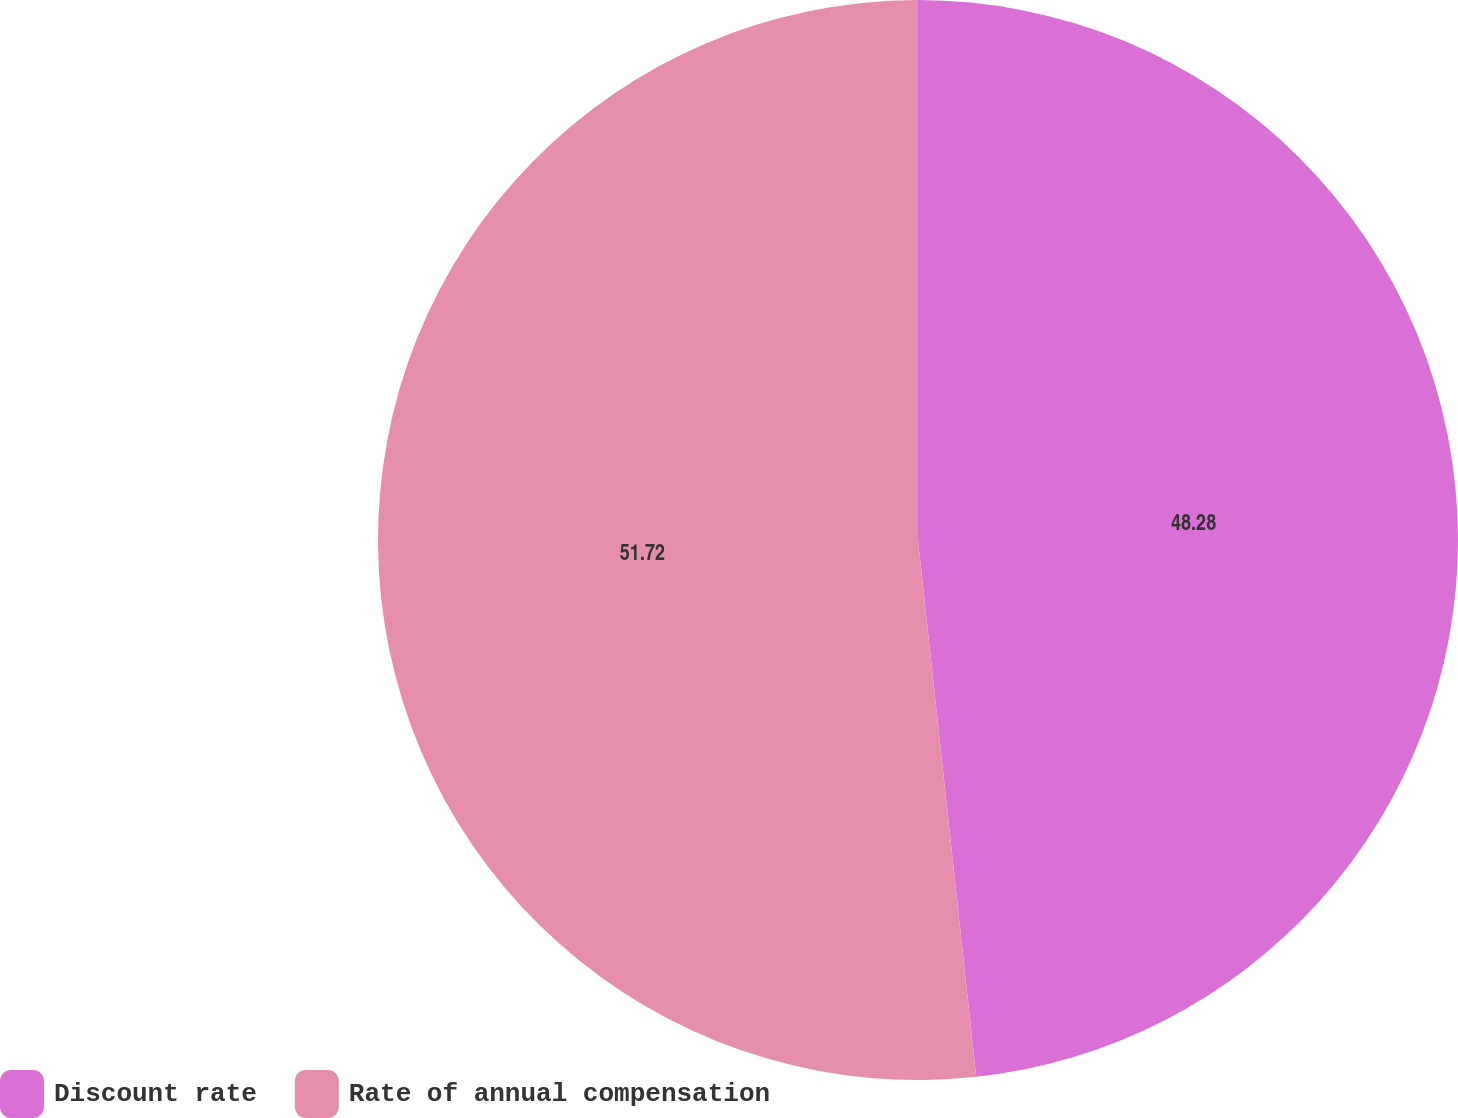<chart> <loc_0><loc_0><loc_500><loc_500><pie_chart><fcel>Discount rate<fcel>Rate of annual compensation<nl><fcel>48.28%<fcel>51.72%<nl></chart> 